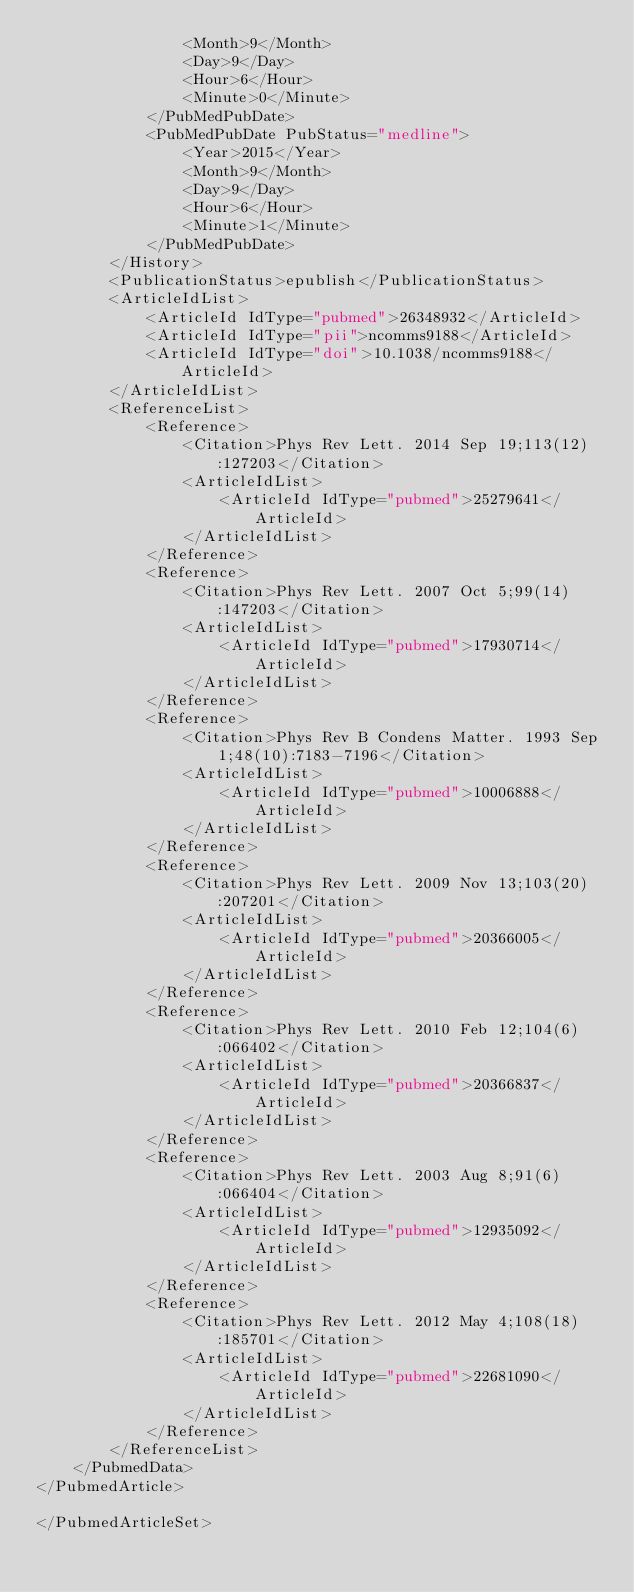<code> <loc_0><loc_0><loc_500><loc_500><_XML_>                <Month>9</Month>
                <Day>9</Day>
                <Hour>6</Hour>
                <Minute>0</Minute>
            </PubMedPubDate>
            <PubMedPubDate PubStatus="medline">
                <Year>2015</Year>
                <Month>9</Month>
                <Day>9</Day>
                <Hour>6</Hour>
                <Minute>1</Minute>
            </PubMedPubDate>
        </History>
        <PublicationStatus>epublish</PublicationStatus>
        <ArticleIdList>
            <ArticleId IdType="pubmed">26348932</ArticleId>
            <ArticleId IdType="pii">ncomms9188</ArticleId>
            <ArticleId IdType="doi">10.1038/ncomms9188</ArticleId>
        </ArticleIdList>
        <ReferenceList>
            <Reference>
                <Citation>Phys Rev Lett. 2014 Sep 19;113(12):127203</Citation>
                <ArticleIdList>
                    <ArticleId IdType="pubmed">25279641</ArticleId>
                </ArticleIdList>
            </Reference>
            <Reference>
                <Citation>Phys Rev Lett. 2007 Oct 5;99(14):147203</Citation>
                <ArticleIdList>
                    <ArticleId IdType="pubmed">17930714</ArticleId>
                </ArticleIdList>
            </Reference>
            <Reference>
                <Citation>Phys Rev B Condens Matter. 1993 Sep 1;48(10):7183-7196</Citation>
                <ArticleIdList>
                    <ArticleId IdType="pubmed">10006888</ArticleId>
                </ArticleIdList>
            </Reference>
            <Reference>
                <Citation>Phys Rev Lett. 2009 Nov 13;103(20):207201</Citation>
                <ArticleIdList>
                    <ArticleId IdType="pubmed">20366005</ArticleId>
                </ArticleIdList>
            </Reference>
            <Reference>
                <Citation>Phys Rev Lett. 2010 Feb 12;104(6):066402</Citation>
                <ArticleIdList>
                    <ArticleId IdType="pubmed">20366837</ArticleId>
                </ArticleIdList>
            </Reference>
            <Reference>
                <Citation>Phys Rev Lett. 2003 Aug 8;91(6):066404</Citation>
                <ArticleIdList>
                    <ArticleId IdType="pubmed">12935092</ArticleId>
                </ArticleIdList>
            </Reference>
            <Reference>
                <Citation>Phys Rev Lett. 2012 May 4;108(18):185701</Citation>
                <ArticleIdList>
                    <ArticleId IdType="pubmed">22681090</ArticleId>
                </ArticleIdList>
            </Reference>
        </ReferenceList>
    </PubmedData>
</PubmedArticle>

</PubmedArticleSet></code> 